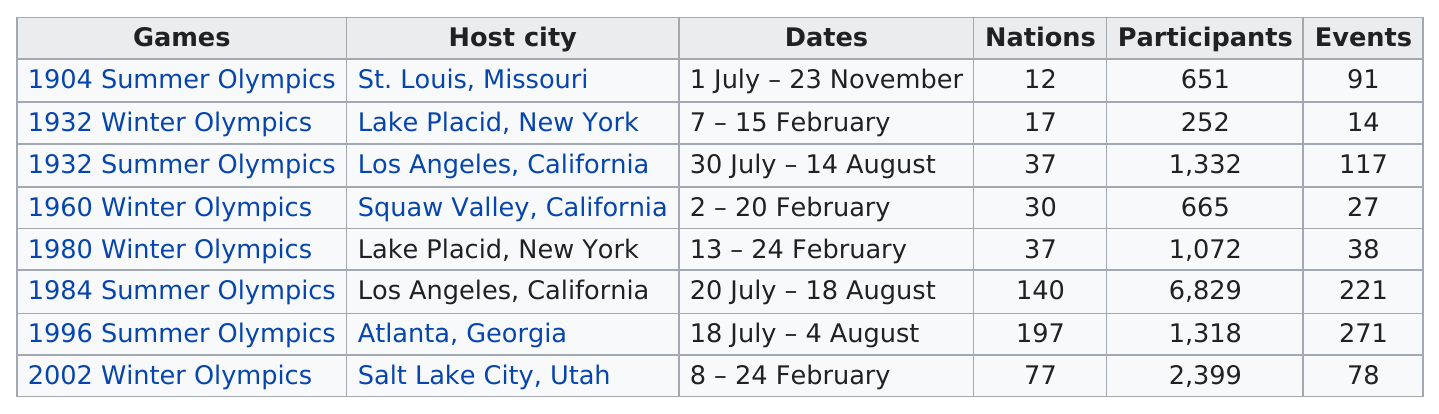Identify some key points in this picture. The 1984 Summer Olympics had the most participants with a record-breaking number of athletes from around the world. The 1996 summer Olympics were attended by 197 participating nations. The 1904 Summer Olympics, the 1932 Winter Olympics, the 1932 Summer Olympics, the 1960 Winter Olympics, and the 1980 Winter Olympics were events that had less than fifty participating nations. The number of participants in the 2002 Winter Olympics in Salt Lake City, Utah, was significantly higher than in the 1932 Winter Olympics in Lake Placid, New York. The 1980 winter Olympics hosted 38 events. 